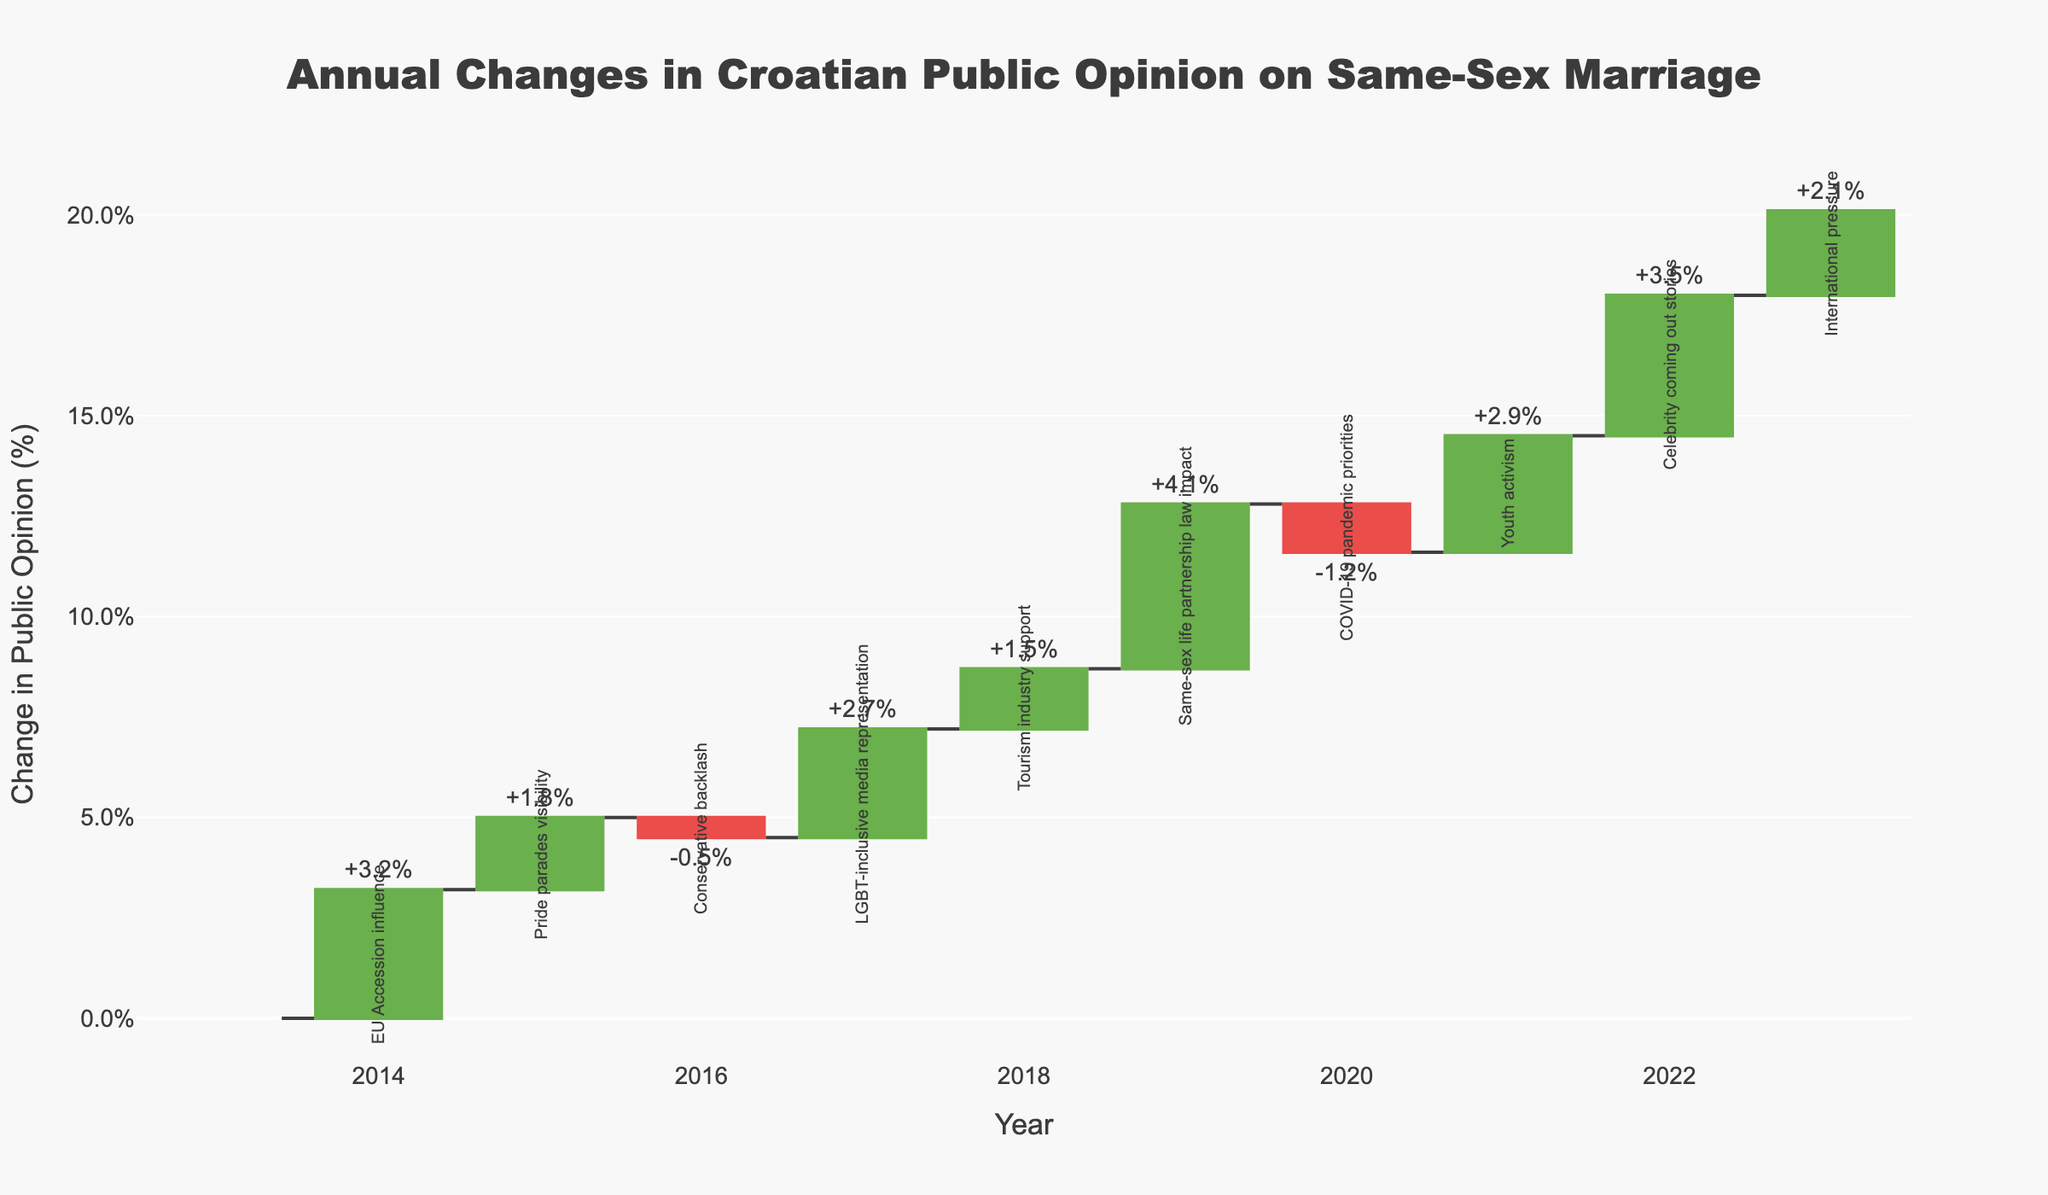What is the title of the chart? The title of the chart is typically found at the top and provides an overview of what the chart is about. Here, it is clearly written.
Answer: Annual Changes in Croatian Public Opinion on Same-Sex Marriage How many years are displayed on the chart? The x-axis of the chart displays the years. Counting the discrete points along this axis will give us the total number of years.
Answer: 11 Which year had the highest positive change in public opinion, and what was the change? By examining the bars reaching higher positive values, we can identify the year with the highest positive change by the height of the bar and the annotation.
Answer: 2019, +4.1% In which year did the public opinion see the most significant negative change, and what was the change? The most substantial negative change can be seen by looking at the bars going downward. The annotation on these bars indicates the exact change.
Answer: 2020, -1.2% Compare the changes in public opinion in 2017 and 2016. Which year saw a more favorable change and by how much? By looking at the respective bars for 2017 and 2016, we can compare the height and direction of these bars. 2017 has a positive change of +2.7%, and 2016 has a negative change of -0.5%. The difference is calculated by adding these values as the sign indicates direction.
Answer: 2017, by 3.2% How much cumulative change in public opinion had occurred by the end of 2023? The cumulative change is depicted by adding the values of each individual year. The final cumulative value after 2023 can be read from the chart or computed by summing all annual changes sequentially.
Answer: +20.1% What factor contributed to the positive change in public opinion in 2014? The factors influencing changes are annotated on the chart near the respective year. Reading the annotation for 2014 will give us the contributing factor.
Answer: EU Accession influence What was the public opinion change in 2013? The value for 2013 is the first bar on the chart and is annotated or directly shown as the baseline, which is typically zero.
Answer: 0 If 2020 had not had a negative change, what would the cumulative public opinion change be by the end of 2023? First, take the cumulative value by the end of 2023 and then add the absolute value of the change in 2020 to this cumulative value because without the negative change, this year would effectively contribute zero. The cumulative change by 2023 is +20.1%, removing -1.2% will make it +21.3%.
Answer: +21.3% What is the total positive change from 2017 to 2022? Total positive change can be found by summing individual positive changes within this period. Those years have: 2017 (+2.7%), 2018 (+1.5%), 2019 (+4.1%), 2021 (+2.9%), 2022 (+3.5%). Summing these values gives the total.
Answer: +14.7% 